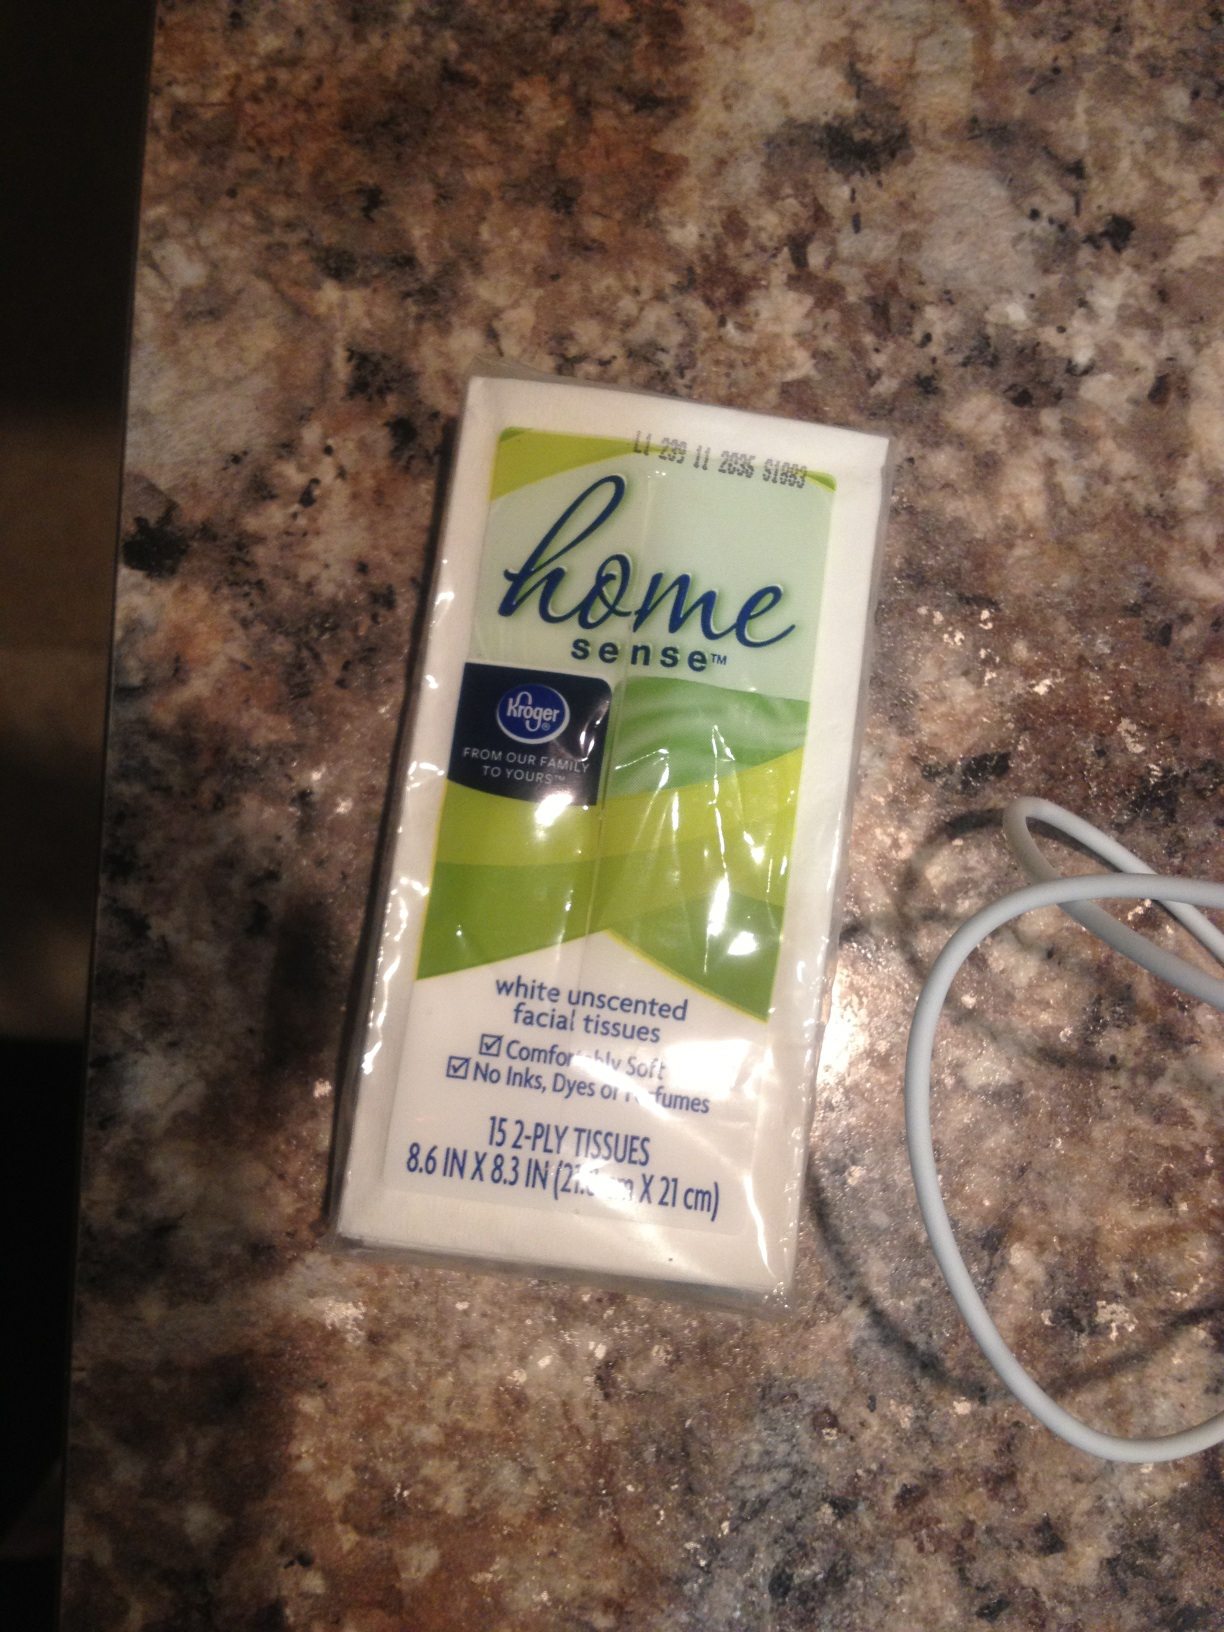Can you tell me an interesting fact about facial tissues? Did you know that facial tissues were first introduced in 1924 by Kimberly-Clark as a way to remove cold cream? They were marketed as a disposable alternative to cloth handkerchiefs, which were commonly reused. Over time, their use expanded, and now they are a staple in households for general hygiene purposes. 